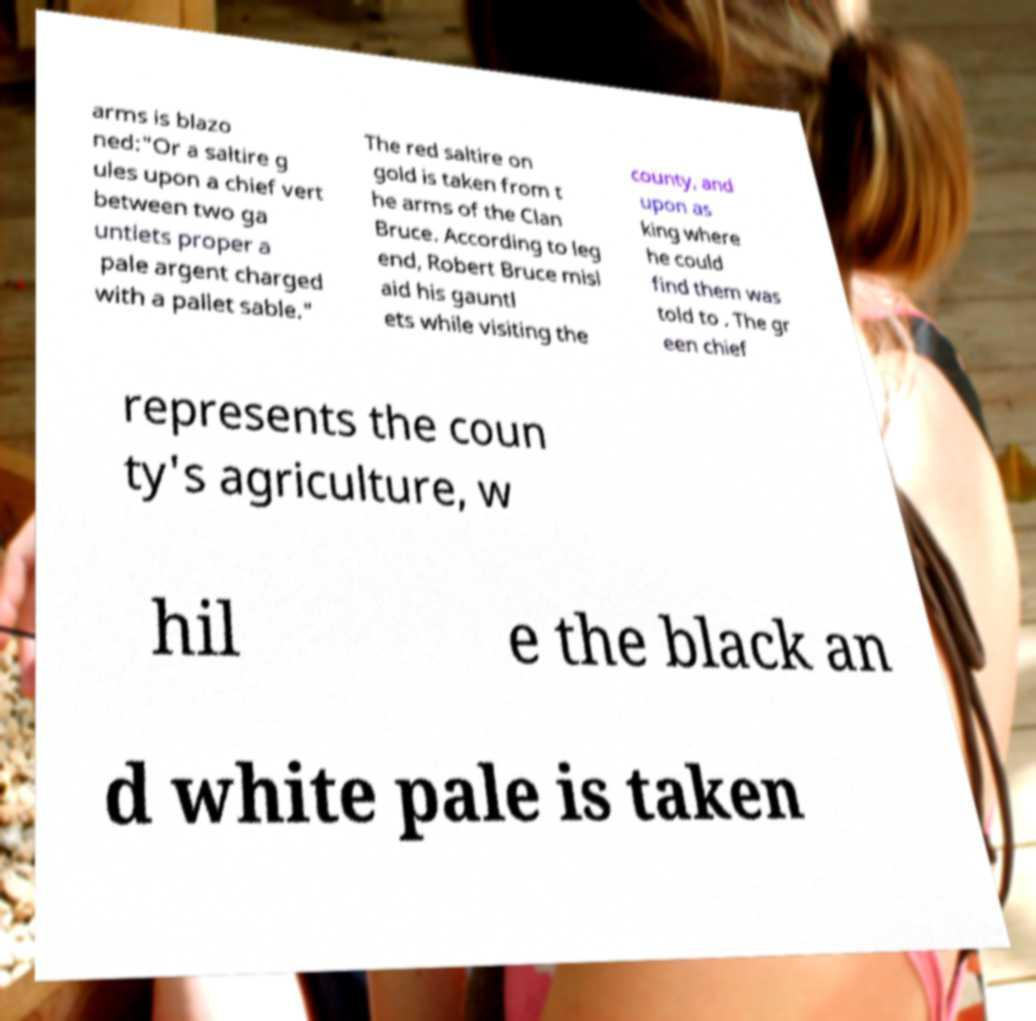Can you accurately transcribe the text from the provided image for me? arms is blazo ned:"Or a saltire g ules upon a chief vert between two ga untlets proper a pale argent charged with a pallet sable." The red saltire on gold is taken from t he arms of the Clan Bruce. According to leg end, Robert Bruce misl aid his gauntl ets while visiting the county, and upon as king where he could find them was told to . The gr een chief represents the coun ty's agriculture, w hil e the black an d white pale is taken 